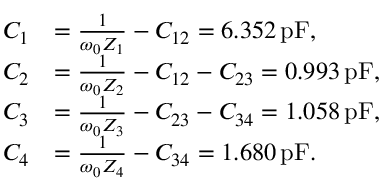<formula> <loc_0><loc_0><loc_500><loc_500>\begin{array} { r l } { C _ { 1 } } & { = \frac { 1 } { \omega _ { 0 } Z _ { 1 } } - C _ { 1 2 } = 6 . 3 5 2 \, p F , } \\ { C _ { 2 } } & { = \frac { 1 } { \omega _ { 0 } Z _ { 2 } } - C _ { 1 2 } - C _ { 2 3 } = 0 . 9 9 3 \, p F , } \\ { C _ { 3 } } & { = \frac { 1 } { \omega _ { 0 } Z _ { 3 } } - C _ { 2 3 } - C _ { 3 4 } = 1 . 0 5 8 \, p F , } \\ { C _ { 4 } } & { = \frac { 1 } { \omega _ { 0 } Z _ { 4 } } - C _ { 3 4 } = 1 . 6 8 0 \, p F . } \end{array}</formula> 